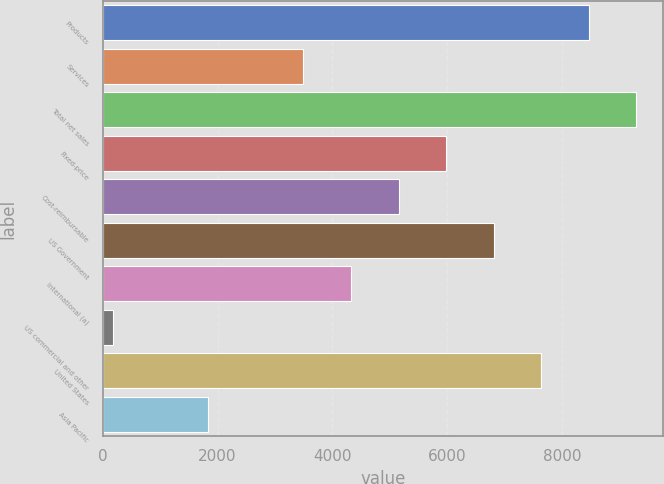Convert chart. <chart><loc_0><loc_0><loc_500><loc_500><bar_chart><fcel>Products<fcel>Services<fcel>Total net sales<fcel>Fixed-price<fcel>Cost-reimbursable<fcel>US Government<fcel>International (a)<fcel>US commercial and other<fcel>United States<fcel>Asia Pacific<nl><fcel>8462<fcel>3495.2<fcel>9289.8<fcel>5978.6<fcel>5150.8<fcel>6806.4<fcel>4323<fcel>184<fcel>7634.2<fcel>1839.6<nl></chart> 